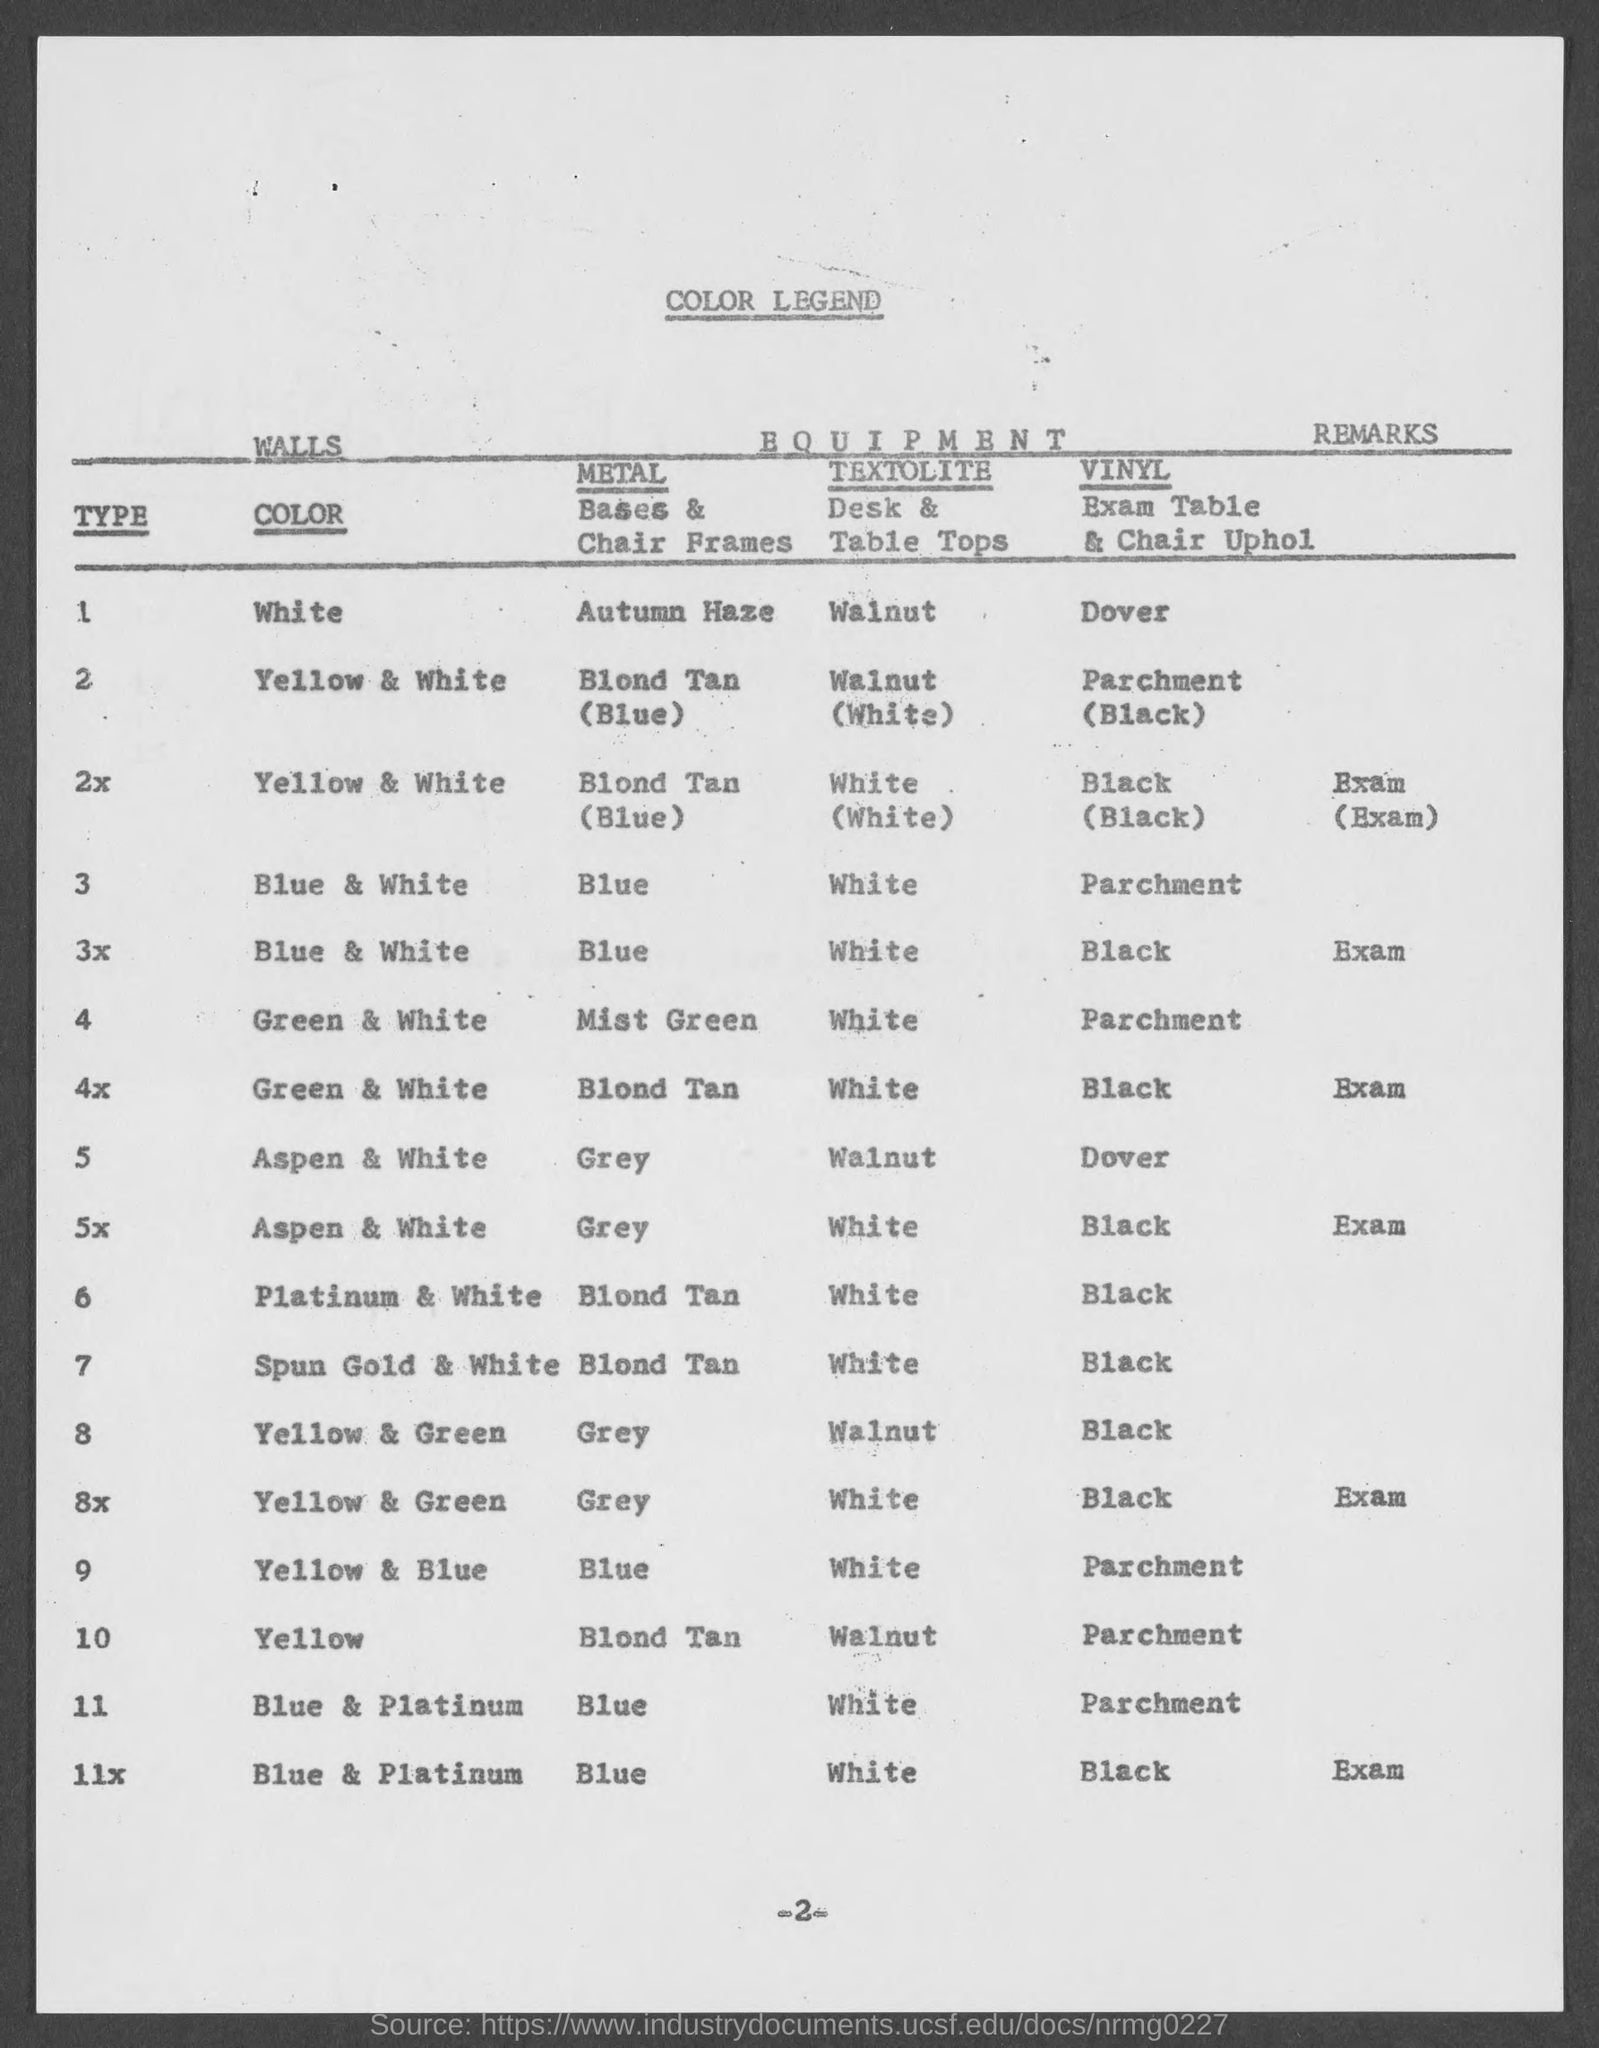What is the title of the document?
Your response must be concise. COLOR LEGEND. What is the page number?
Give a very brief answer. -2-. What is the type of color "White?"
Provide a short and direct response. 1. What is the metal in color yellow?
Keep it short and to the point. BLOND TAN. What is the type of color "Yellow?"
Give a very brief answer. 10. 